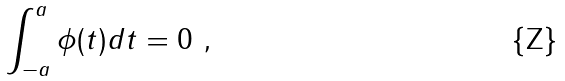<formula> <loc_0><loc_0><loc_500><loc_500>\int _ { - a } ^ { a } \phi ( t ) d t = 0 \ ,</formula> 